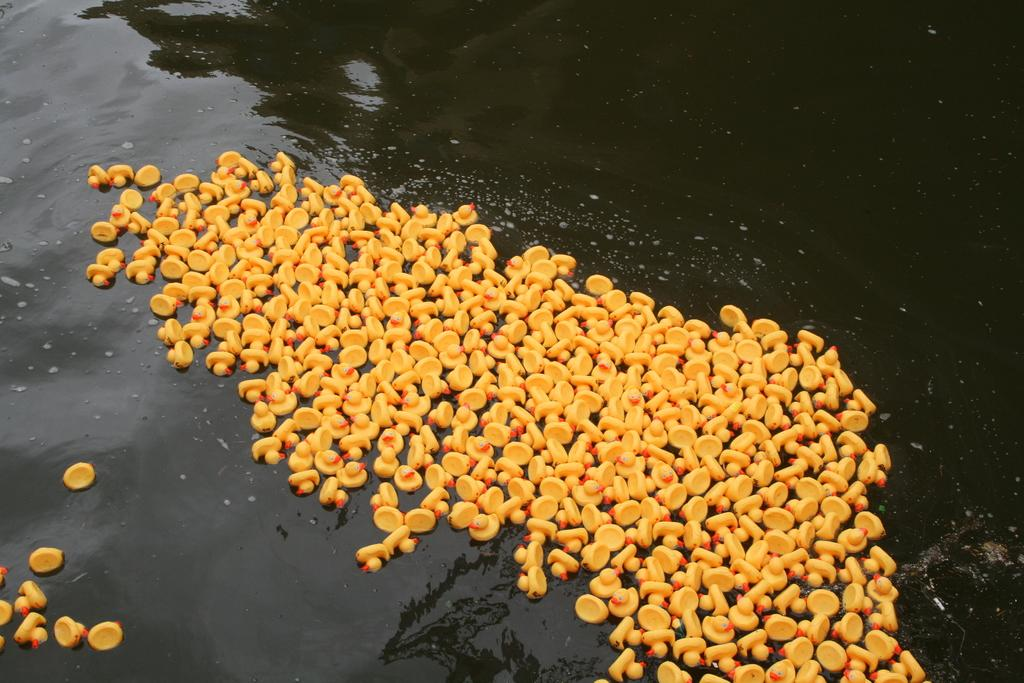What type of toys are in the image? There are toy ducks in the image. Where are the toy ducks located in the image? The toy ducks are in the center of the image. What is the toy ducks' position in relation to the water? The toy ducks are on the water surface. What type of bucket is being used by the servant in the image? There is no bucket or servant present in the image; it only features toy ducks on the water surface. 